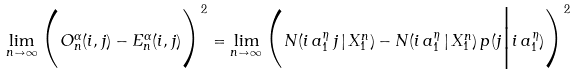Convert formula to latex. <formula><loc_0><loc_0><loc_500><loc_500>\lim _ { n \to \infty } \Big ( O _ { n } ^ { \alpha } ( i , j ) - E _ { n } ^ { \alpha } ( i , j ) \Big ) ^ { 2 } = \lim _ { n \to \infty } \Big ( N ( i \, a _ { 1 } ^ { \eta } \, j \, | \, X _ { 1 } ^ { n } ) - N ( i \, a _ { 1 } ^ { \eta } \, | \, X _ { 1 } ^ { n } ) \, p ( j \Big | { i \, a _ { 1 } ^ { \eta } } ) \Big ) ^ { 2 }</formula> 